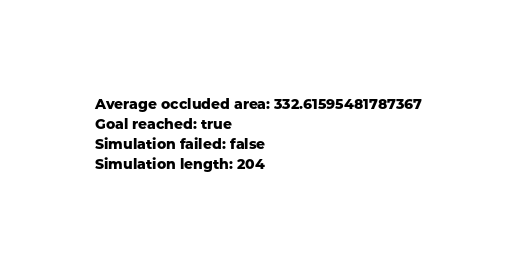Convert code to text. <code><loc_0><loc_0><loc_500><loc_500><_YAML_>Average occluded area: 332.61595481787367
Goal reached: true
Simulation failed: false
Simulation length: 204
</code> 